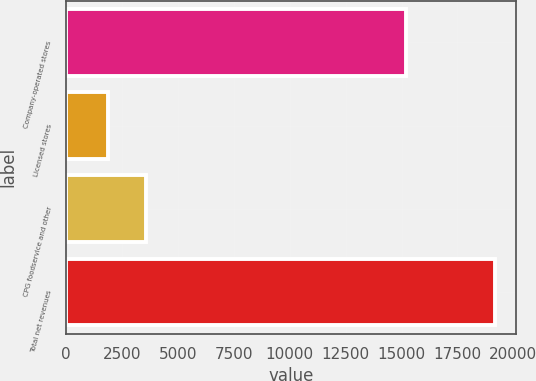<chart> <loc_0><loc_0><loc_500><loc_500><bar_chart><fcel>Company-operated stores<fcel>Licensed stores<fcel>CPG foodservice and other<fcel>Total net revenues<nl><fcel>15197.3<fcel>1861.9<fcel>3591.98<fcel>19162.7<nl></chart> 